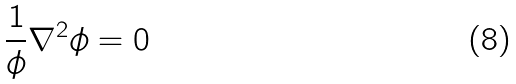<formula> <loc_0><loc_0><loc_500><loc_500>\frac { 1 } { \phi } \nabla ^ { 2 } \phi = 0</formula> 